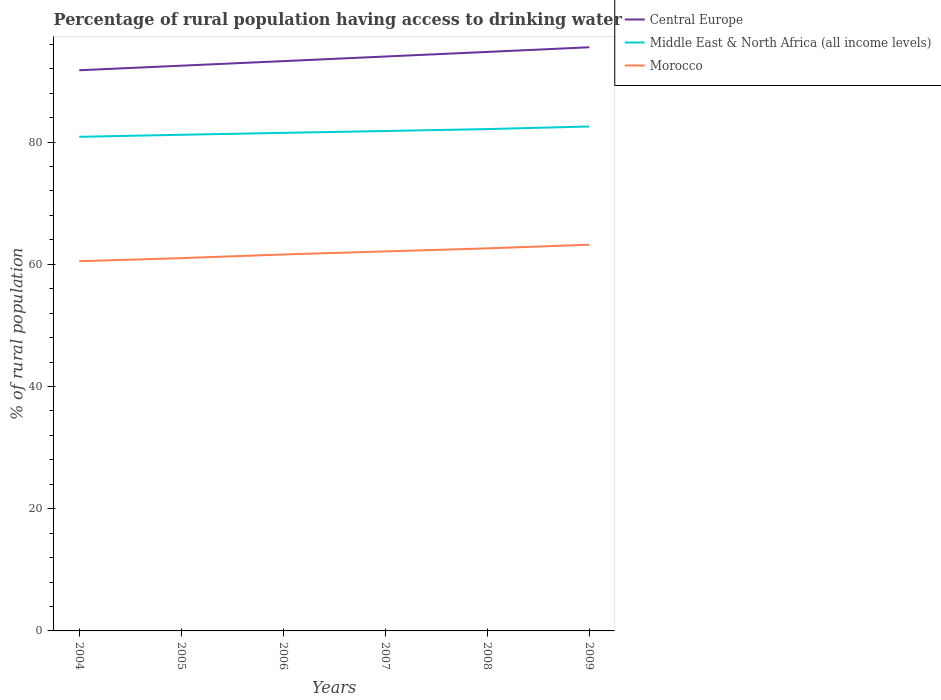Is the number of lines equal to the number of legend labels?
Make the answer very short. Yes. Across all years, what is the maximum percentage of rural population having access to drinking water in Morocco?
Give a very brief answer. 60.5. What is the total percentage of rural population having access to drinking water in Morocco in the graph?
Provide a succinct answer. -0.6. What is the difference between the highest and the second highest percentage of rural population having access to drinking water in Middle East & North Africa (all income levels)?
Provide a short and direct response. 1.69. What is the difference between the highest and the lowest percentage of rural population having access to drinking water in Middle East & North Africa (all income levels)?
Provide a short and direct response. 3. Is the percentage of rural population having access to drinking water in Middle East & North Africa (all income levels) strictly greater than the percentage of rural population having access to drinking water in Morocco over the years?
Your answer should be very brief. No. Are the values on the major ticks of Y-axis written in scientific E-notation?
Your answer should be very brief. No. Does the graph contain any zero values?
Give a very brief answer. No. Does the graph contain grids?
Offer a very short reply. No. How are the legend labels stacked?
Provide a succinct answer. Vertical. What is the title of the graph?
Give a very brief answer. Percentage of rural population having access to drinking water. Does "Northern Mariana Islands" appear as one of the legend labels in the graph?
Provide a succinct answer. No. What is the label or title of the X-axis?
Your answer should be very brief. Years. What is the label or title of the Y-axis?
Keep it short and to the point. % of rural population. What is the % of rural population in Central Europe in 2004?
Provide a short and direct response. 91.75. What is the % of rural population of Middle East & North Africa (all income levels) in 2004?
Provide a short and direct response. 80.85. What is the % of rural population in Morocco in 2004?
Your answer should be compact. 60.5. What is the % of rural population in Central Europe in 2005?
Provide a succinct answer. 92.49. What is the % of rural population in Middle East & North Africa (all income levels) in 2005?
Ensure brevity in your answer.  81.19. What is the % of rural population in Morocco in 2005?
Your response must be concise. 61. What is the % of rural population of Central Europe in 2006?
Offer a very short reply. 93.24. What is the % of rural population in Middle East & North Africa (all income levels) in 2006?
Your response must be concise. 81.5. What is the % of rural population in Morocco in 2006?
Provide a short and direct response. 61.6. What is the % of rural population of Central Europe in 2007?
Your response must be concise. 93.99. What is the % of rural population in Middle East & North Africa (all income levels) in 2007?
Your response must be concise. 81.8. What is the % of rural population in Morocco in 2007?
Give a very brief answer. 62.1. What is the % of rural population of Central Europe in 2008?
Give a very brief answer. 94.74. What is the % of rural population in Middle East & North Africa (all income levels) in 2008?
Make the answer very short. 82.12. What is the % of rural population of Morocco in 2008?
Make the answer very short. 62.6. What is the % of rural population of Central Europe in 2009?
Your answer should be very brief. 95.51. What is the % of rural population in Middle East & North Africa (all income levels) in 2009?
Your response must be concise. 82.54. What is the % of rural population in Morocco in 2009?
Your answer should be compact. 63.2. Across all years, what is the maximum % of rural population of Central Europe?
Offer a very short reply. 95.51. Across all years, what is the maximum % of rural population in Middle East & North Africa (all income levels)?
Provide a succinct answer. 82.54. Across all years, what is the maximum % of rural population of Morocco?
Your answer should be compact. 63.2. Across all years, what is the minimum % of rural population of Central Europe?
Your response must be concise. 91.75. Across all years, what is the minimum % of rural population in Middle East & North Africa (all income levels)?
Keep it short and to the point. 80.85. Across all years, what is the minimum % of rural population of Morocco?
Provide a short and direct response. 60.5. What is the total % of rural population of Central Europe in the graph?
Your answer should be very brief. 561.72. What is the total % of rural population in Middle East & North Africa (all income levels) in the graph?
Give a very brief answer. 490. What is the total % of rural population in Morocco in the graph?
Offer a very short reply. 371. What is the difference between the % of rural population in Central Europe in 2004 and that in 2005?
Provide a succinct answer. -0.75. What is the difference between the % of rural population of Middle East & North Africa (all income levels) in 2004 and that in 2005?
Offer a very short reply. -0.34. What is the difference between the % of rural population in Morocco in 2004 and that in 2005?
Offer a terse response. -0.5. What is the difference between the % of rural population of Central Europe in 2004 and that in 2006?
Provide a succinct answer. -1.49. What is the difference between the % of rural population of Middle East & North Africa (all income levels) in 2004 and that in 2006?
Your answer should be very brief. -0.65. What is the difference between the % of rural population of Morocco in 2004 and that in 2006?
Provide a succinct answer. -1.1. What is the difference between the % of rural population in Central Europe in 2004 and that in 2007?
Provide a short and direct response. -2.25. What is the difference between the % of rural population of Middle East & North Africa (all income levels) in 2004 and that in 2007?
Your answer should be compact. -0.95. What is the difference between the % of rural population of Morocco in 2004 and that in 2007?
Make the answer very short. -1.6. What is the difference between the % of rural population of Central Europe in 2004 and that in 2008?
Provide a short and direct response. -3. What is the difference between the % of rural population of Middle East & North Africa (all income levels) in 2004 and that in 2008?
Provide a short and direct response. -1.27. What is the difference between the % of rural population in Central Europe in 2004 and that in 2009?
Offer a very short reply. -3.76. What is the difference between the % of rural population of Middle East & North Africa (all income levels) in 2004 and that in 2009?
Provide a succinct answer. -1.69. What is the difference between the % of rural population in Morocco in 2004 and that in 2009?
Offer a terse response. -2.7. What is the difference between the % of rural population in Central Europe in 2005 and that in 2006?
Offer a terse response. -0.74. What is the difference between the % of rural population in Middle East & North Africa (all income levels) in 2005 and that in 2006?
Make the answer very short. -0.31. What is the difference between the % of rural population in Central Europe in 2005 and that in 2007?
Keep it short and to the point. -1.5. What is the difference between the % of rural population in Middle East & North Africa (all income levels) in 2005 and that in 2007?
Provide a short and direct response. -0.61. What is the difference between the % of rural population in Morocco in 2005 and that in 2007?
Your answer should be very brief. -1.1. What is the difference between the % of rural population of Central Europe in 2005 and that in 2008?
Your answer should be very brief. -2.25. What is the difference between the % of rural population in Middle East & North Africa (all income levels) in 2005 and that in 2008?
Offer a terse response. -0.93. What is the difference between the % of rural population in Morocco in 2005 and that in 2008?
Your answer should be very brief. -1.6. What is the difference between the % of rural population of Central Europe in 2005 and that in 2009?
Keep it short and to the point. -3.01. What is the difference between the % of rural population of Middle East & North Africa (all income levels) in 2005 and that in 2009?
Provide a succinct answer. -1.35. What is the difference between the % of rural population in Morocco in 2005 and that in 2009?
Keep it short and to the point. -2.2. What is the difference between the % of rural population in Central Europe in 2006 and that in 2007?
Keep it short and to the point. -0.76. What is the difference between the % of rural population of Middle East & North Africa (all income levels) in 2006 and that in 2007?
Keep it short and to the point. -0.3. What is the difference between the % of rural population in Central Europe in 2006 and that in 2008?
Your answer should be very brief. -1.51. What is the difference between the % of rural population of Middle East & North Africa (all income levels) in 2006 and that in 2008?
Your response must be concise. -0.62. What is the difference between the % of rural population of Morocco in 2006 and that in 2008?
Make the answer very short. -1. What is the difference between the % of rural population in Central Europe in 2006 and that in 2009?
Give a very brief answer. -2.27. What is the difference between the % of rural population in Middle East & North Africa (all income levels) in 2006 and that in 2009?
Ensure brevity in your answer.  -1.04. What is the difference between the % of rural population of Central Europe in 2007 and that in 2008?
Ensure brevity in your answer.  -0.75. What is the difference between the % of rural population of Middle East & North Africa (all income levels) in 2007 and that in 2008?
Your answer should be compact. -0.32. What is the difference between the % of rural population of Morocco in 2007 and that in 2008?
Offer a very short reply. -0.5. What is the difference between the % of rural population in Central Europe in 2007 and that in 2009?
Ensure brevity in your answer.  -1.51. What is the difference between the % of rural population of Middle East & North Africa (all income levels) in 2007 and that in 2009?
Offer a very short reply. -0.74. What is the difference between the % of rural population of Morocco in 2007 and that in 2009?
Your answer should be very brief. -1.1. What is the difference between the % of rural population of Central Europe in 2008 and that in 2009?
Provide a short and direct response. -0.76. What is the difference between the % of rural population of Middle East & North Africa (all income levels) in 2008 and that in 2009?
Your answer should be compact. -0.42. What is the difference between the % of rural population of Morocco in 2008 and that in 2009?
Make the answer very short. -0.6. What is the difference between the % of rural population in Central Europe in 2004 and the % of rural population in Middle East & North Africa (all income levels) in 2005?
Make the answer very short. 10.56. What is the difference between the % of rural population of Central Europe in 2004 and the % of rural population of Morocco in 2005?
Your answer should be very brief. 30.75. What is the difference between the % of rural population in Middle East & North Africa (all income levels) in 2004 and the % of rural population in Morocco in 2005?
Give a very brief answer. 19.85. What is the difference between the % of rural population of Central Europe in 2004 and the % of rural population of Middle East & North Africa (all income levels) in 2006?
Provide a short and direct response. 10.25. What is the difference between the % of rural population in Central Europe in 2004 and the % of rural population in Morocco in 2006?
Give a very brief answer. 30.15. What is the difference between the % of rural population of Middle East & North Africa (all income levels) in 2004 and the % of rural population of Morocco in 2006?
Ensure brevity in your answer.  19.25. What is the difference between the % of rural population in Central Europe in 2004 and the % of rural population in Middle East & North Africa (all income levels) in 2007?
Provide a short and direct response. 9.94. What is the difference between the % of rural population of Central Europe in 2004 and the % of rural population of Morocco in 2007?
Provide a succinct answer. 29.65. What is the difference between the % of rural population of Middle East & North Africa (all income levels) in 2004 and the % of rural population of Morocco in 2007?
Provide a short and direct response. 18.75. What is the difference between the % of rural population of Central Europe in 2004 and the % of rural population of Middle East & North Africa (all income levels) in 2008?
Give a very brief answer. 9.63. What is the difference between the % of rural population in Central Europe in 2004 and the % of rural population in Morocco in 2008?
Provide a succinct answer. 29.15. What is the difference between the % of rural population in Middle East & North Africa (all income levels) in 2004 and the % of rural population in Morocco in 2008?
Offer a terse response. 18.25. What is the difference between the % of rural population in Central Europe in 2004 and the % of rural population in Middle East & North Africa (all income levels) in 2009?
Offer a terse response. 9.2. What is the difference between the % of rural population of Central Europe in 2004 and the % of rural population of Morocco in 2009?
Your answer should be compact. 28.55. What is the difference between the % of rural population of Middle East & North Africa (all income levels) in 2004 and the % of rural population of Morocco in 2009?
Your response must be concise. 17.65. What is the difference between the % of rural population in Central Europe in 2005 and the % of rural population in Middle East & North Africa (all income levels) in 2006?
Provide a short and direct response. 10.99. What is the difference between the % of rural population of Central Europe in 2005 and the % of rural population of Morocco in 2006?
Your answer should be very brief. 30.89. What is the difference between the % of rural population in Middle East & North Africa (all income levels) in 2005 and the % of rural population in Morocco in 2006?
Provide a succinct answer. 19.59. What is the difference between the % of rural population in Central Europe in 2005 and the % of rural population in Middle East & North Africa (all income levels) in 2007?
Your answer should be very brief. 10.69. What is the difference between the % of rural population in Central Europe in 2005 and the % of rural population in Morocco in 2007?
Ensure brevity in your answer.  30.39. What is the difference between the % of rural population in Middle East & North Africa (all income levels) in 2005 and the % of rural population in Morocco in 2007?
Provide a succinct answer. 19.09. What is the difference between the % of rural population of Central Europe in 2005 and the % of rural population of Middle East & North Africa (all income levels) in 2008?
Offer a very short reply. 10.37. What is the difference between the % of rural population in Central Europe in 2005 and the % of rural population in Morocco in 2008?
Keep it short and to the point. 29.89. What is the difference between the % of rural population in Middle East & North Africa (all income levels) in 2005 and the % of rural population in Morocco in 2008?
Provide a short and direct response. 18.59. What is the difference between the % of rural population of Central Europe in 2005 and the % of rural population of Middle East & North Africa (all income levels) in 2009?
Your answer should be very brief. 9.95. What is the difference between the % of rural population in Central Europe in 2005 and the % of rural population in Morocco in 2009?
Your answer should be compact. 29.29. What is the difference between the % of rural population of Middle East & North Africa (all income levels) in 2005 and the % of rural population of Morocco in 2009?
Your answer should be very brief. 17.99. What is the difference between the % of rural population of Central Europe in 2006 and the % of rural population of Middle East & North Africa (all income levels) in 2007?
Your answer should be compact. 11.43. What is the difference between the % of rural population in Central Europe in 2006 and the % of rural population in Morocco in 2007?
Keep it short and to the point. 31.14. What is the difference between the % of rural population of Middle East & North Africa (all income levels) in 2006 and the % of rural population of Morocco in 2007?
Your answer should be very brief. 19.4. What is the difference between the % of rural population of Central Europe in 2006 and the % of rural population of Middle East & North Africa (all income levels) in 2008?
Provide a short and direct response. 11.12. What is the difference between the % of rural population of Central Europe in 2006 and the % of rural population of Morocco in 2008?
Your answer should be very brief. 30.64. What is the difference between the % of rural population in Middle East & North Africa (all income levels) in 2006 and the % of rural population in Morocco in 2008?
Your response must be concise. 18.9. What is the difference between the % of rural population of Central Europe in 2006 and the % of rural population of Middle East & North Africa (all income levels) in 2009?
Make the answer very short. 10.69. What is the difference between the % of rural population in Central Europe in 2006 and the % of rural population in Morocco in 2009?
Your answer should be very brief. 30.04. What is the difference between the % of rural population of Middle East & North Africa (all income levels) in 2006 and the % of rural population of Morocco in 2009?
Ensure brevity in your answer.  18.3. What is the difference between the % of rural population in Central Europe in 2007 and the % of rural population in Middle East & North Africa (all income levels) in 2008?
Provide a succinct answer. 11.87. What is the difference between the % of rural population in Central Europe in 2007 and the % of rural population in Morocco in 2008?
Your answer should be very brief. 31.39. What is the difference between the % of rural population in Middle East & North Africa (all income levels) in 2007 and the % of rural population in Morocco in 2008?
Your response must be concise. 19.2. What is the difference between the % of rural population of Central Europe in 2007 and the % of rural population of Middle East & North Africa (all income levels) in 2009?
Offer a terse response. 11.45. What is the difference between the % of rural population of Central Europe in 2007 and the % of rural population of Morocco in 2009?
Provide a short and direct response. 30.79. What is the difference between the % of rural population in Middle East & North Africa (all income levels) in 2007 and the % of rural population in Morocco in 2009?
Your answer should be very brief. 18.6. What is the difference between the % of rural population in Central Europe in 2008 and the % of rural population in Middle East & North Africa (all income levels) in 2009?
Provide a short and direct response. 12.2. What is the difference between the % of rural population in Central Europe in 2008 and the % of rural population in Morocco in 2009?
Your answer should be very brief. 31.54. What is the difference between the % of rural population of Middle East & North Africa (all income levels) in 2008 and the % of rural population of Morocco in 2009?
Ensure brevity in your answer.  18.92. What is the average % of rural population in Central Europe per year?
Your answer should be very brief. 93.62. What is the average % of rural population in Middle East & North Africa (all income levels) per year?
Make the answer very short. 81.67. What is the average % of rural population in Morocco per year?
Keep it short and to the point. 61.83. In the year 2004, what is the difference between the % of rural population in Central Europe and % of rural population in Middle East & North Africa (all income levels)?
Offer a very short reply. 10.89. In the year 2004, what is the difference between the % of rural population in Central Europe and % of rural population in Morocco?
Provide a succinct answer. 31.25. In the year 2004, what is the difference between the % of rural population in Middle East & North Africa (all income levels) and % of rural population in Morocco?
Ensure brevity in your answer.  20.35. In the year 2005, what is the difference between the % of rural population of Central Europe and % of rural population of Middle East & North Africa (all income levels)?
Provide a succinct answer. 11.31. In the year 2005, what is the difference between the % of rural population of Central Europe and % of rural population of Morocco?
Your response must be concise. 31.49. In the year 2005, what is the difference between the % of rural population in Middle East & North Africa (all income levels) and % of rural population in Morocco?
Ensure brevity in your answer.  20.19. In the year 2006, what is the difference between the % of rural population of Central Europe and % of rural population of Middle East & North Africa (all income levels)?
Give a very brief answer. 11.74. In the year 2006, what is the difference between the % of rural population of Central Europe and % of rural population of Morocco?
Your answer should be compact. 31.64. In the year 2006, what is the difference between the % of rural population in Middle East & North Africa (all income levels) and % of rural population in Morocco?
Your response must be concise. 19.9. In the year 2007, what is the difference between the % of rural population of Central Europe and % of rural population of Middle East & North Africa (all income levels)?
Ensure brevity in your answer.  12.19. In the year 2007, what is the difference between the % of rural population in Central Europe and % of rural population in Morocco?
Provide a succinct answer. 31.89. In the year 2007, what is the difference between the % of rural population of Middle East & North Africa (all income levels) and % of rural population of Morocco?
Give a very brief answer. 19.7. In the year 2008, what is the difference between the % of rural population of Central Europe and % of rural population of Middle East & North Africa (all income levels)?
Your answer should be very brief. 12.62. In the year 2008, what is the difference between the % of rural population in Central Europe and % of rural population in Morocco?
Ensure brevity in your answer.  32.14. In the year 2008, what is the difference between the % of rural population of Middle East & North Africa (all income levels) and % of rural population of Morocco?
Offer a very short reply. 19.52. In the year 2009, what is the difference between the % of rural population of Central Europe and % of rural population of Middle East & North Africa (all income levels)?
Ensure brevity in your answer.  12.96. In the year 2009, what is the difference between the % of rural population of Central Europe and % of rural population of Morocco?
Your answer should be very brief. 32.31. In the year 2009, what is the difference between the % of rural population of Middle East & North Africa (all income levels) and % of rural population of Morocco?
Provide a succinct answer. 19.34. What is the ratio of the % of rural population of Central Europe in 2004 to that in 2006?
Provide a short and direct response. 0.98. What is the ratio of the % of rural population of Morocco in 2004 to that in 2006?
Keep it short and to the point. 0.98. What is the ratio of the % of rural population of Central Europe in 2004 to that in 2007?
Provide a succinct answer. 0.98. What is the ratio of the % of rural population of Middle East & North Africa (all income levels) in 2004 to that in 2007?
Your answer should be very brief. 0.99. What is the ratio of the % of rural population in Morocco in 2004 to that in 2007?
Offer a very short reply. 0.97. What is the ratio of the % of rural population of Central Europe in 2004 to that in 2008?
Make the answer very short. 0.97. What is the ratio of the % of rural population in Middle East & North Africa (all income levels) in 2004 to that in 2008?
Make the answer very short. 0.98. What is the ratio of the % of rural population of Morocco in 2004 to that in 2008?
Keep it short and to the point. 0.97. What is the ratio of the % of rural population in Central Europe in 2004 to that in 2009?
Your answer should be very brief. 0.96. What is the ratio of the % of rural population in Middle East & North Africa (all income levels) in 2004 to that in 2009?
Give a very brief answer. 0.98. What is the ratio of the % of rural population in Morocco in 2004 to that in 2009?
Provide a short and direct response. 0.96. What is the ratio of the % of rural population of Middle East & North Africa (all income levels) in 2005 to that in 2006?
Offer a very short reply. 1. What is the ratio of the % of rural population of Morocco in 2005 to that in 2006?
Give a very brief answer. 0.99. What is the ratio of the % of rural population of Morocco in 2005 to that in 2007?
Provide a short and direct response. 0.98. What is the ratio of the % of rural population of Central Europe in 2005 to that in 2008?
Provide a succinct answer. 0.98. What is the ratio of the % of rural population in Middle East & North Africa (all income levels) in 2005 to that in 2008?
Offer a very short reply. 0.99. What is the ratio of the % of rural population in Morocco in 2005 to that in 2008?
Make the answer very short. 0.97. What is the ratio of the % of rural population of Central Europe in 2005 to that in 2009?
Offer a very short reply. 0.97. What is the ratio of the % of rural population of Middle East & North Africa (all income levels) in 2005 to that in 2009?
Provide a succinct answer. 0.98. What is the ratio of the % of rural population of Morocco in 2005 to that in 2009?
Your answer should be very brief. 0.97. What is the ratio of the % of rural population of Middle East & North Africa (all income levels) in 2006 to that in 2007?
Ensure brevity in your answer.  1. What is the ratio of the % of rural population in Central Europe in 2006 to that in 2008?
Provide a short and direct response. 0.98. What is the ratio of the % of rural population in Morocco in 2006 to that in 2008?
Your answer should be compact. 0.98. What is the ratio of the % of rural population of Central Europe in 2006 to that in 2009?
Keep it short and to the point. 0.98. What is the ratio of the % of rural population in Middle East & North Africa (all income levels) in 2006 to that in 2009?
Provide a short and direct response. 0.99. What is the ratio of the % of rural population in Morocco in 2006 to that in 2009?
Give a very brief answer. 0.97. What is the ratio of the % of rural population of Middle East & North Africa (all income levels) in 2007 to that in 2008?
Make the answer very short. 1. What is the ratio of the % of rural population in Morocco in 2007 to that in 2008?
Your answer should be very brief. 0.99. What is the ratio of the % of rural population of Central Europe in 2007 to that in 2009?
Ensure brevity in your answer.  0.98. What is the ratio of the % of rural population in Morocco in 2007 to that in 2009?
Your answer should be very brief. 0.98. What is the ratio of the % of rural population of Central Europe in 2008 to that in 2009?
Make the answer very short. 0.99. What is the difference between the highest and the second highest % of rural population in Central Europe?
Offer a very short reply. 0.76. What is the difference between the highest and the second highest % of rural population of Middle East & North Africa (all income levels)?
Your response must be concise. 0.42. What is the difference between the highest and the lowest % of rural population in Central Europe?
Your answer should be compact. 3.76. What is the difference between the highest and the lowest % of rural population in Middle East & North Africa (all income levels)?
Give a very brief answer. 1.69. 